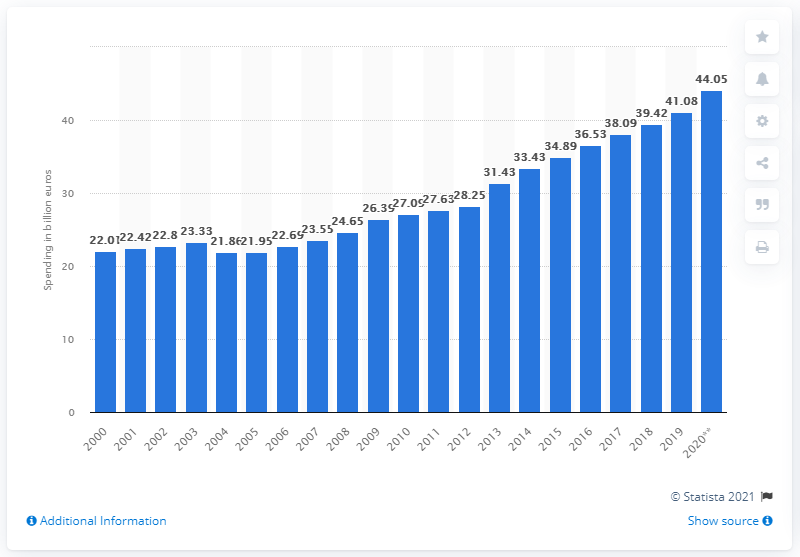Outline some significant characteristics in this image. The expenditures on medical treatment in Germany in 2020 amounted to 44.05. The previous year's expenditure on medical treatment in Germany was 41.08... 